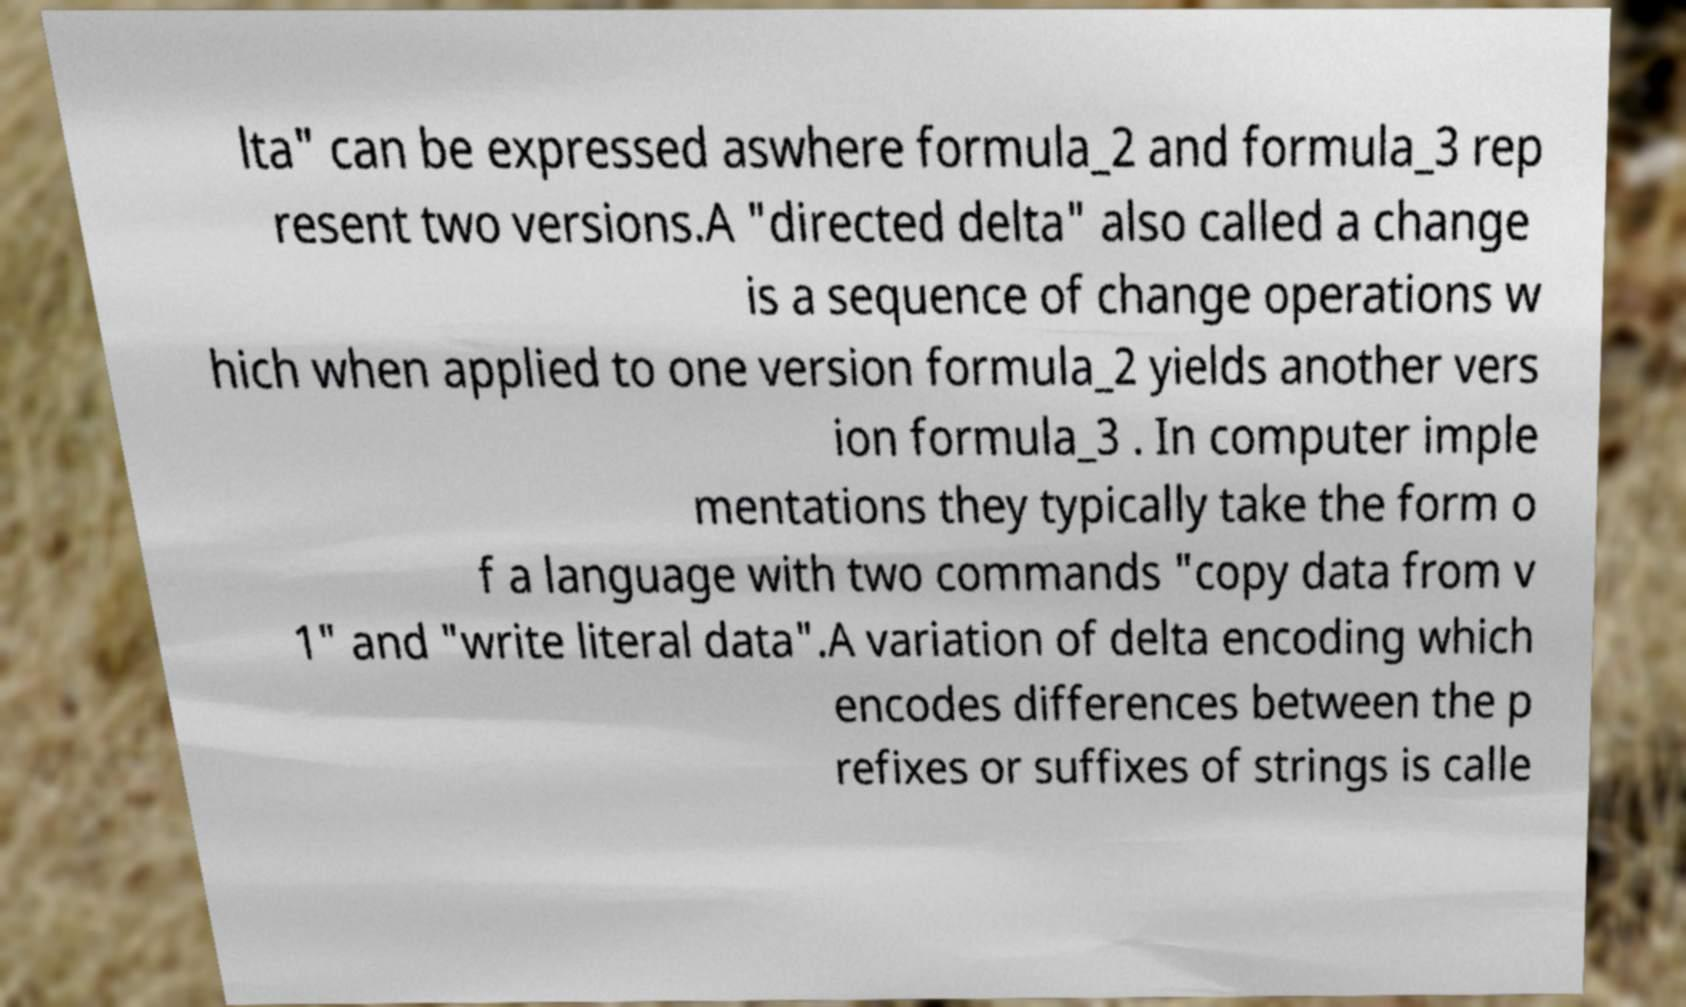Please read and relay the text visible in this image. What does it say? lta" can be expressed aswhere formula_2 and formula_3 rep resent two versions.A "directed delta" also called a change is a sequence of change operations w hich when applied to one version formula_2 yields another vers ion formula_3 . In computer imple mentations they typically take the form o f a language with two commands "copy data from v 1" and "write literal data".A variation of delta encoding which encodes differences between the p refixes or suffixes of strings is calle 